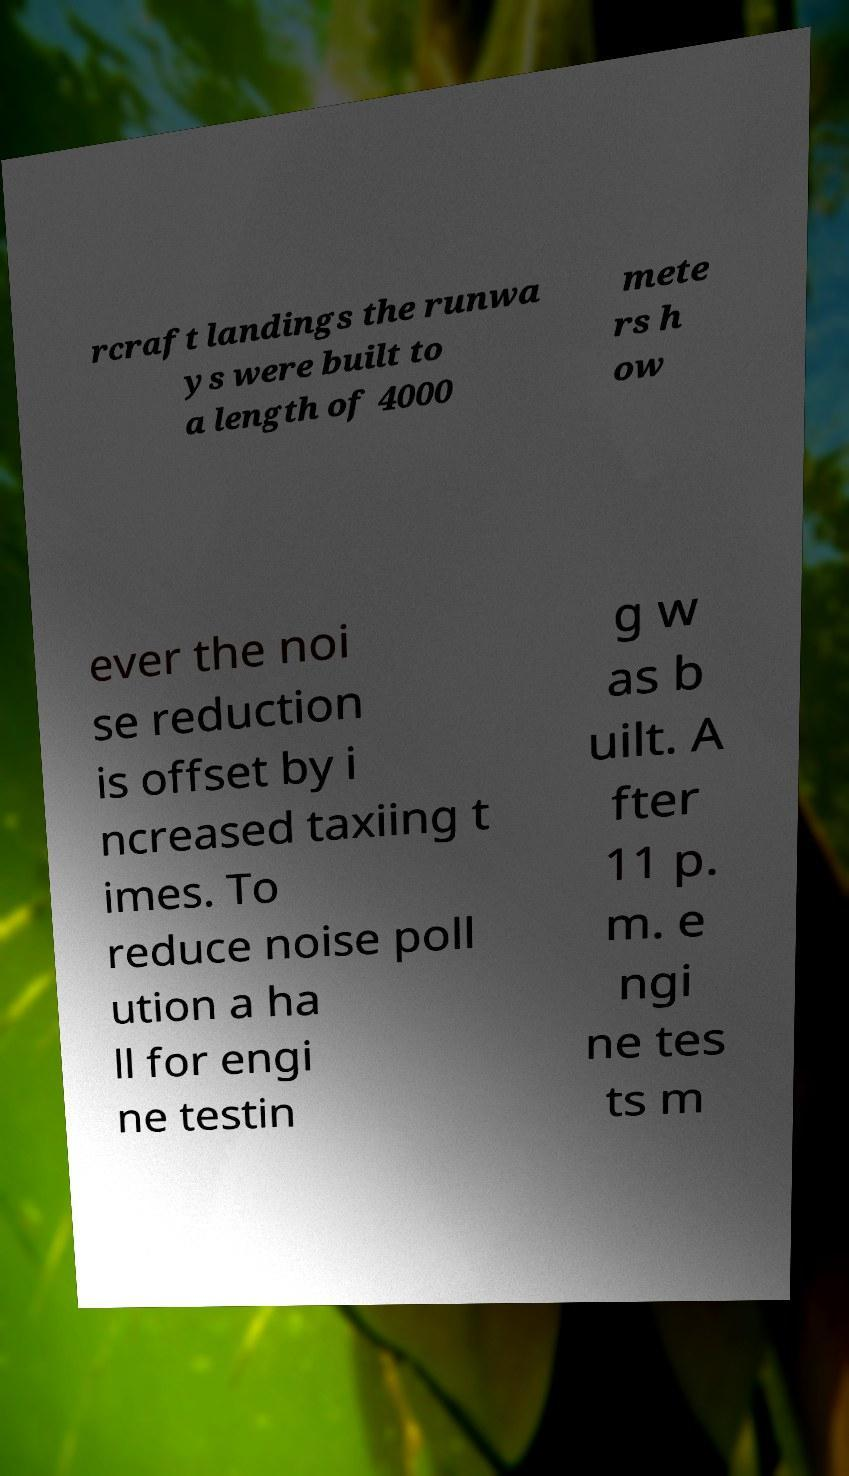Please identify and transcribe the text found in this image. rcraft landings the runwa ys were built to a length of 4000 mete rs h ow ever the noi se reduction is offset by i ncreased taxiing t imes. To reduce noise poll ution a ha ll for engi ne testin g w as b uilt. A fter 11 p. m. e ngi ne tes ts m 